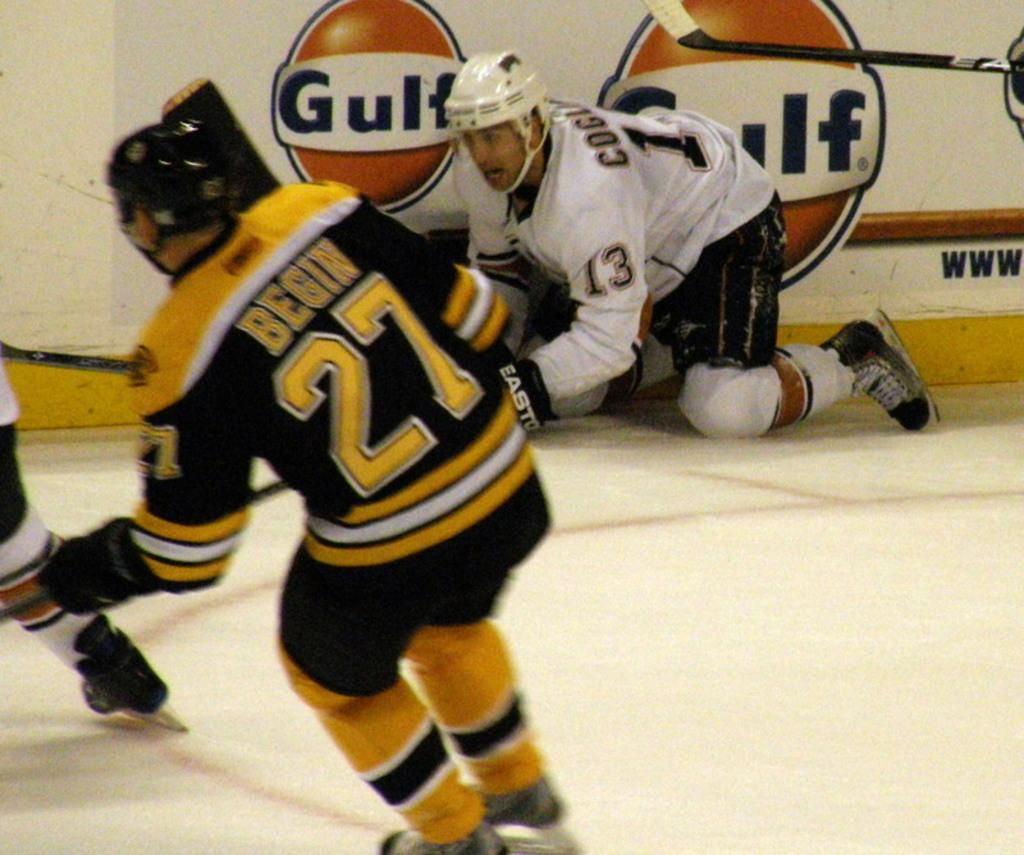What activity are the men in the image engaged in? The men are playing ice hockey. What surface are they sliding on? They are sliding on an ice floor. What can be seen in the background of the image? There is a wall in the background of the image. Can you see a stream of water flowing near the ice hockey players in the image? No, there is no stream of water visible in the image. 